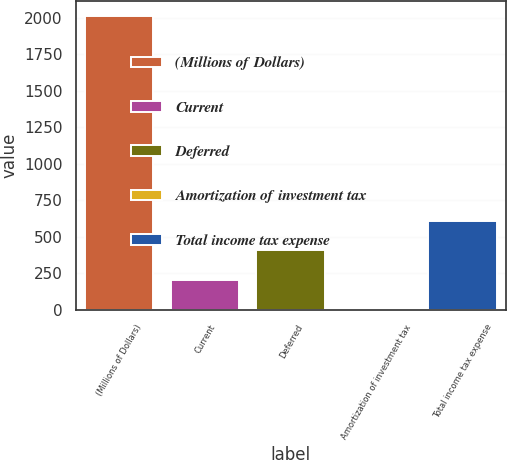Convert chart to OTSL. <chart><loc_0><loc_0><loc_500><loc_500><bar_chart><fcel>(Millions of Dollars)<fcel>Current<fcel>Deferred<fcel>Amortization of investment tax<fcel>Total income tax expense<nl><fcel>2012<fcel>205.7<fcel>406.4<fcel>5<fcel>607.1<nl></chart> 